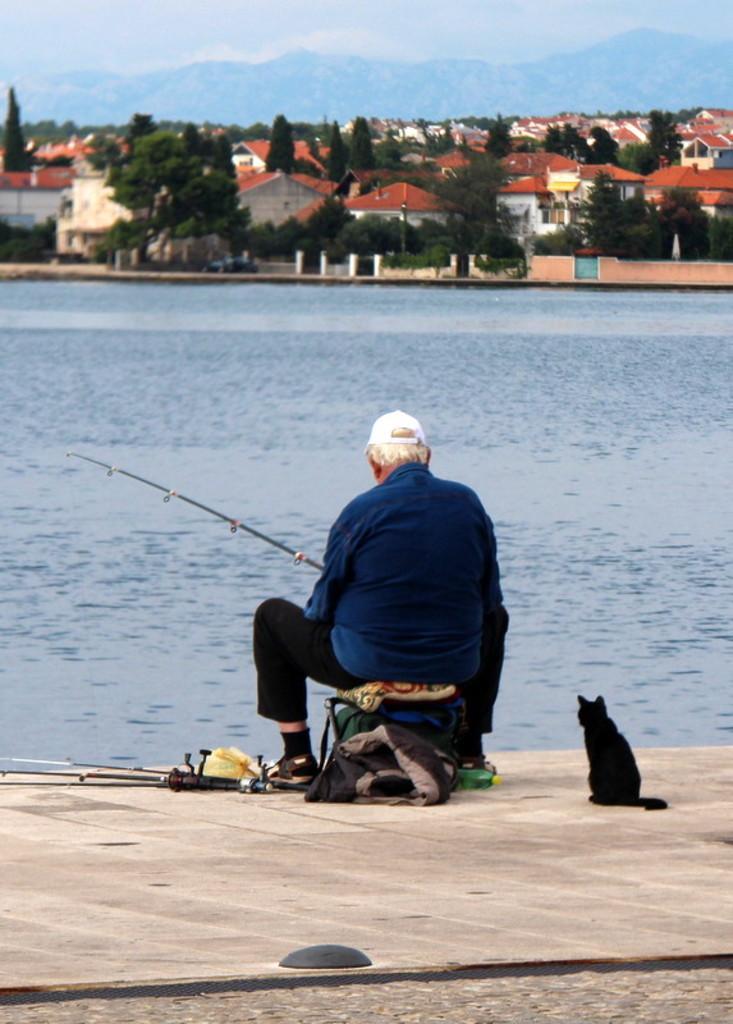In one or two sentences, can you explain what this image depicts? In this picture we can see old man sitting on the chair. Besides him we can see jacket, cloth, stand and plastic covers. He is wearing shirt, trouser, cap and shoe. He is also holding the fishing stick. Besides him we can see a cat. Here we can see water. On the background we can see many trees, buildings and mountains. On the top we can see sky and clouds. 